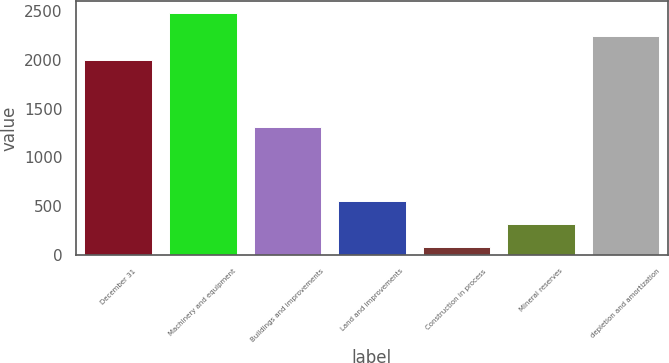Convert chart to OTSL. <chart><loc_0><loc_0><loc_500><loc_500><bar_chart><fcel>December 31<fcel>Machinery and equipment<fcel>Buildings and improvements<fcel>Land and improvements<fcel>Construction in process<fcel>Mineral reserves<fcel>depletion and amortization<nl><fcel>2004<fcel>2483.4<fcel>1311<fcel>557.4<fcel>78<fcel>317.7<fcel>2243.7<nl></chart> 